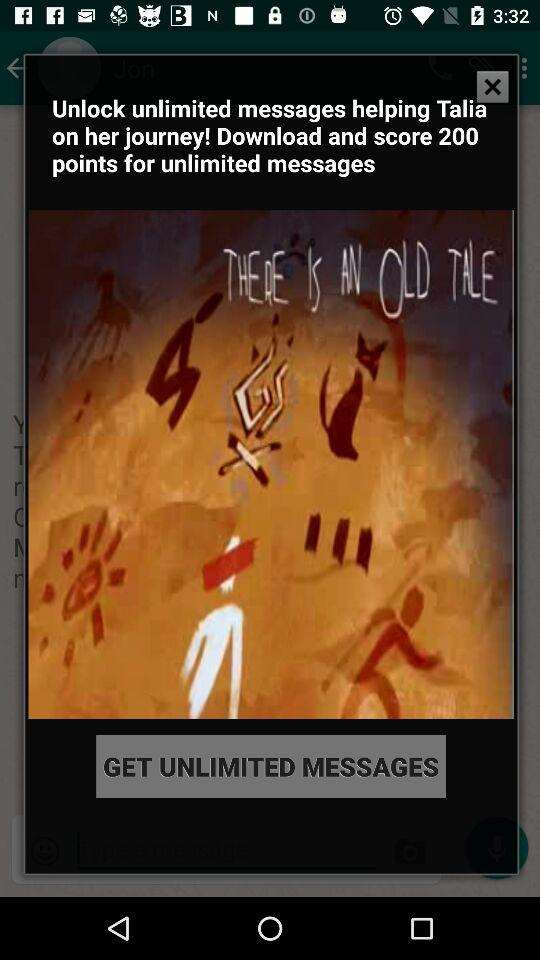How many more points do I need to unlock unlimited messages?
Answer the question using a single word or phrase. 200 